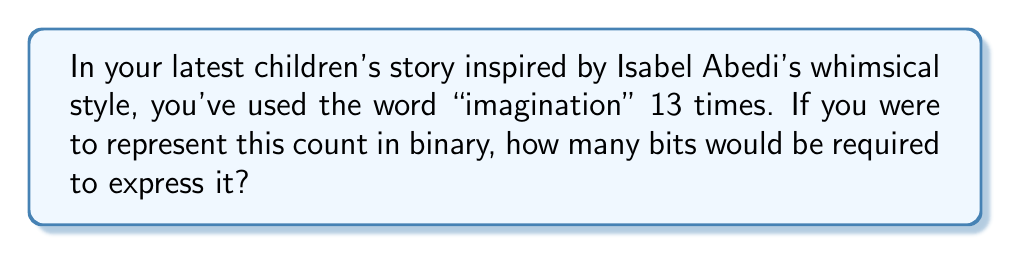Could you help me with this problem? To solve this problem, we need to convert the decimal number 13 to its binary representation and count the number of bits required. Let's follow these steps:

1) First, let's convert 13 to binary:
   
   $13 = 1 \times 2^3 + 1 \times 2^2 + 0 \times 2^1 + 1 \times 2^0$

   So, 13 in binary is 1101.

2) Now, let's count the bits:
   
   $$1101_2$$

   We can see that this binary number uses 4 bits.

3) To verify, we can check the range of numbers that can be represented with 4 bits:
   
   With 4 bits, we can represent numbers from $0$ (0000) to $15$ (1111).

   $$2^4 - 1 = 16 - 1 = 15$$

   So, 4 bits can indeed represent the number 13.

4) If we were to use only 3 bits, the maximum number we could represent would be:

   $$2^3 - 1 = 8 - 1 = 7$$

   Which is not enough to represent 13.

Therefore, 4 bits are required to represent the number 13 in binary.
Answer: 4 bits 